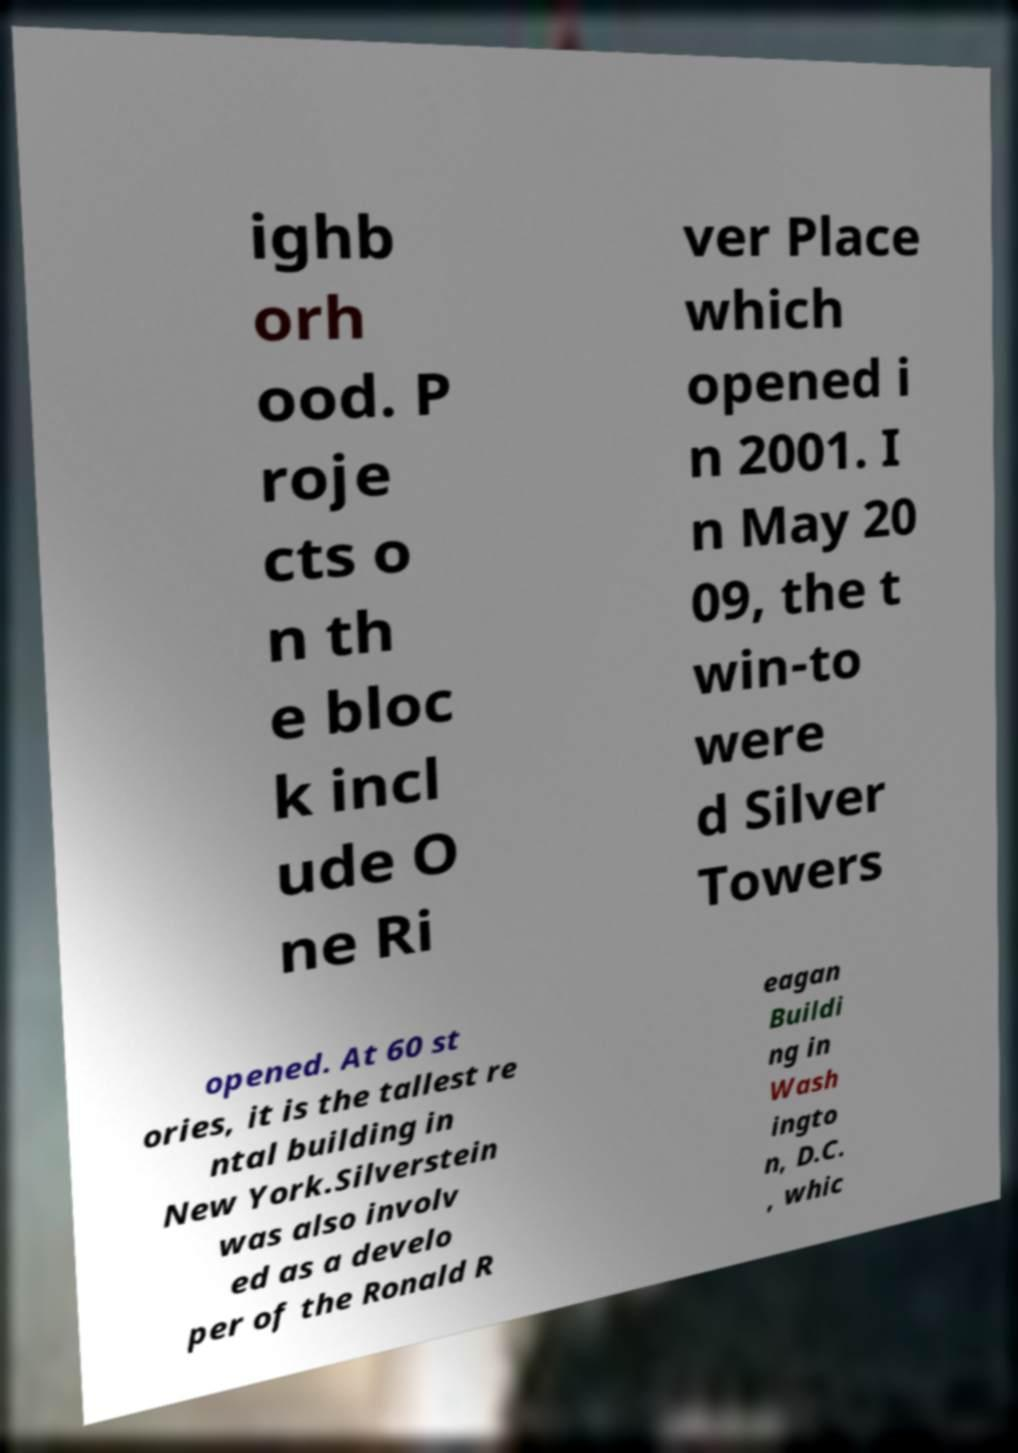Can you accurately transcribe the text from the provided image for me? ighb orh ood. P roje cts o n th e bloc k incl ude O ne Ri ver Place which opened i n 2001. I n May 20 09, the t win-to were d Silver Towers opened. At 60 st ories, it is the tallest re ntal building in New York.Silverstein was also involv ed as a develo per of the Ronald R eagan Buildi ng in Wash ingto n, D.C. , whic 